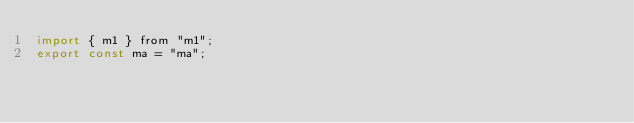<code> <loc_0><loc_0><loc_500><loc_500><_JavaScript_>import { m1 } from "m1";
export const ma = "ma";</code> 